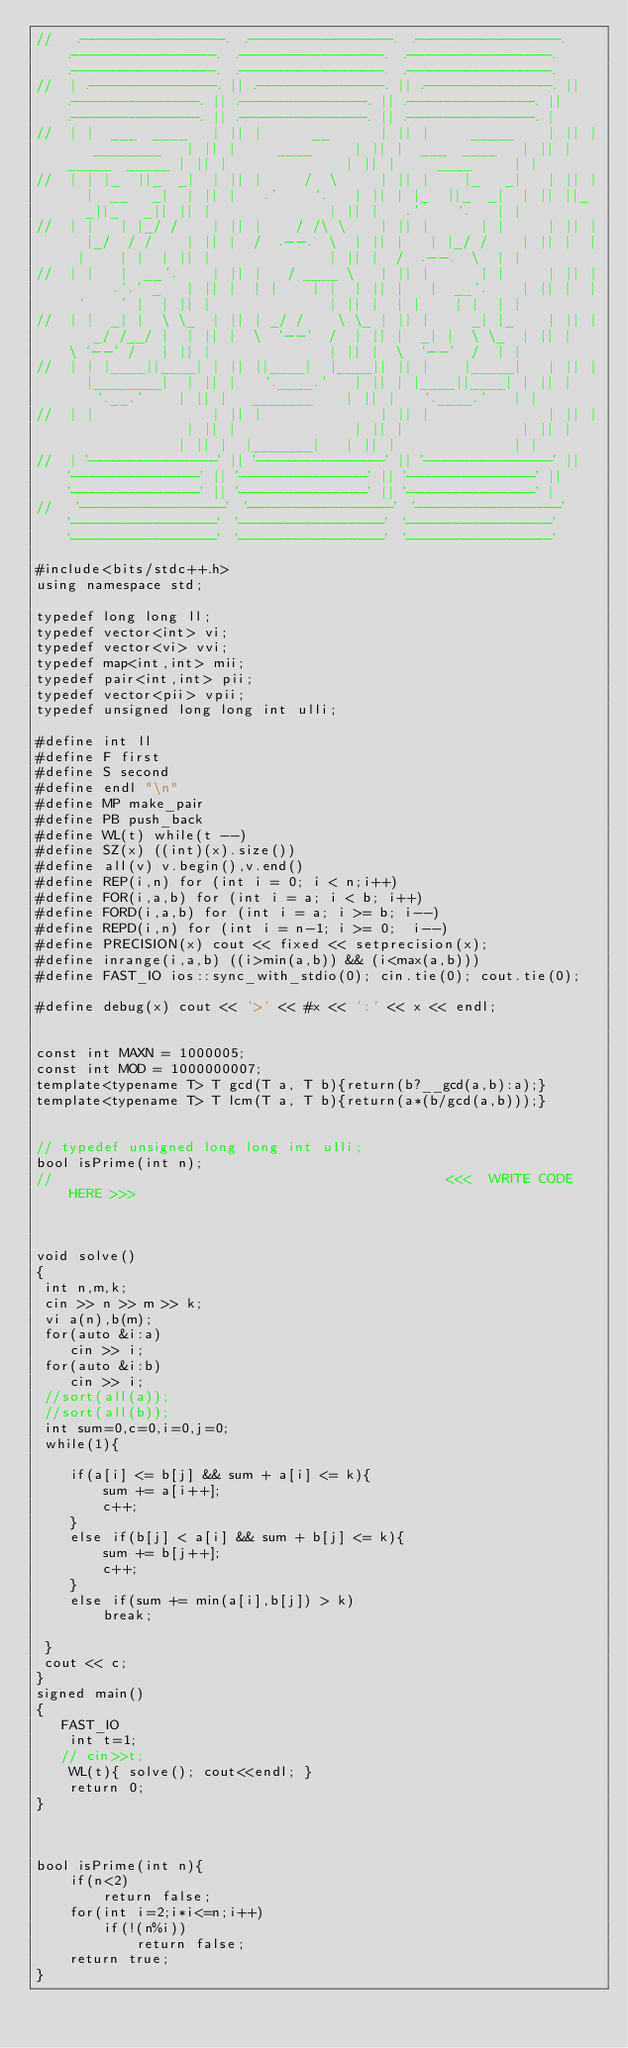<code> <loc_0><loc_0><loc_500><loc_500><_C++_>//   .----------------.  .----------------.  .----------------.  .----------------.  .----------------.  .----------------.  .----------------.  .----------------.  .----------------. 
//  | .--------------. || .--------------. || .--------------. || .--------------. || .--------------. || .--------------. || .--------------. || .--------------. || .--------------. |
//  | |  ___  ____   | || |      __      | || |     _____    | || |   ________   | || |     ____     | || |  ___  ____   | || | _____  _____ | || |              | || |     ____     | |
//  | | |_  ||_  _|  | || |     /  \     | || |    |_   _|   | || |  |  __   _|  | || |   .'    `.   | || | |_  ||_  _|  | || ||_   _||_   _|| || |              | || |   .'    `.   | |
//  | |   | |_/ /    | || |    / /\ \    | || |      | |     | || |  |_/  / /    | || |  /  .--.  \  | || |   | |_/ /    | || |  | |    | |  | || |              | || |  /  .--.  \  | |
//  | |   |  __'.    | || |   / ____ \   | || |      | |     | || |     .'.' _   | || |  | |    | |  | || |   |  __'.    | || |  | '    ' |  | || |              | || |  | |    | |  | |
//  | |  _| |  \ \_  | || | _/ /    \ \_ | || |     _| |_    | || |   _/ /__/ |  | || |  \  `--'  /  | || |  _| |  \ \_  | || |   \ `--' /   | || |              | || |  \  `--'  /  | |
//  | | |____||____| | || ||____|  |____|| || |    |_____|   | || |  |________|  | || |   `.____.'   | || | |____||____| | || |    `.__.'    | || |   _______    | || |   `.____.'   | |
//  | |              | || |              | || |              | || |              | || |              | || |              | || |              | || |  |_______|   | || |              | |
//  | '--------------' || '--------------' || '--------------' || '--------------' || '--------------' || '--------------' || '--------------' || '--------------' || '--------------' |
//   '----------------'  '----------------'  '----------------'  '----------------'  '----------------'  '----------------'  '----------------'  '----------------'  '----------------' 

#include<bits/stdc++.h>
using namespace std;

typedef long long ll;
typedef vector<int> vi; 
typedef vector<vi> vvi; 
typedef map<int,int> mii;
typedef pair<int,int> pii; 
typedef vector<pii> vpii; 
typedef unsigned long long int ulli;

#define int ll
#define F first 
#define S second
#define endl "\n"
#define MP make_pair
#define PB push_back
#define WL(t) while(t --) 
#define SZ(x) ((int)(x).size()) 
#define all(v) v.begin(),v.end()
#define REP(i,n) for (int i = 0; i < n;i++) 
#define FOR(i,a,b) for (int i = a; i < b; i++) 
#define FORD(i,a,b) for (int i = a; i >= b; i--)
#define REPD(i,n) for (int i = n-1; i >= 0;  i--) 
#define PRECISION(x) cout << fixed << setprecision(x);  
#define inrange(i,a,b) ((i>min(a,b)) && (i<max(a,b))) 
#define FAST_IO ios::sync_with_stdio(0); cin.tie(0); cout.tie(0);

#define debug(x) cout << '>' << #x << ':' << x << endl;


const int MAXN = 1000005; 
const int MOD = 1000000007; 
template<typename T> T gcd(T a, T b){return(b?__gcd(a,b):a);} 
template<typename T> T lcm(T a, T b){return(a*(b/gcd(a,b)));} 

 
// typedef unsigned long long int ulli;
bool isPrime(int n);
//                                               <<<  WRITE CODE HERE >>>



void solve()
{   
 int n,m,k;
 cin >> n >> m >> k;
 vi a(n),b(m);
 for(auto &i:a)
    cin >> i;
 for(auto &i:b)
    cin >> i;
 //sort(all(a));
 //sort(all(b));
 int sum=0,c=0,i=0,j=0;
 while(1){
   
    if(a[i] <= b[j] && sum + a[i] <= k){
        sum += a[i++];
        c++;
    }
    else if(b[j] < a[i] && sum + b[j] <= k){
        sum += b[j++];
        c++;
    }
    else if(sum += min(a[i],b[j]) > k)
        break;

 }
 cout << c;
}
signed main()
{   
   FAST_IO
    int t=1;
   // cin>>t;   
    WL(t){ solve(); cout<<endl; }
    return 0;
}



bool isPrime(int n){
    if(n<2)
        return false;
    for(int i=2;i*i<=n;i++)
        if(!(n%i))
            return false;
    return true;
}
</code> 